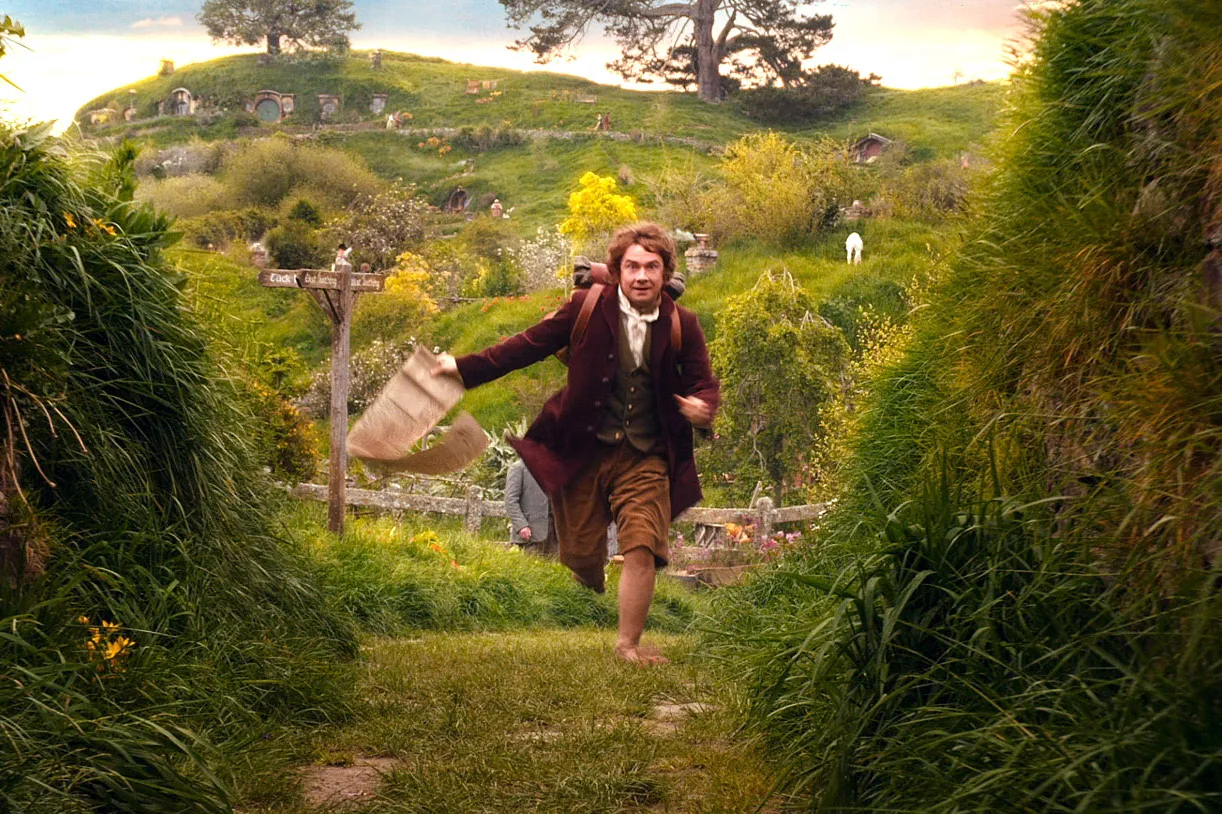If the signpost pointing to 'Bag End' could talk, what would it say? 'Ah, another adventurous soul heads my way! Welcome to Bag End, a place of wonder and unexpected journeys. Old Bilbo Baggins resides here, a hobbit with a heart full of tales and a history richer than the treasures hoarded by dragons. Come closer, and perhaps you'll find yourself part of a new story yet to be told!' 